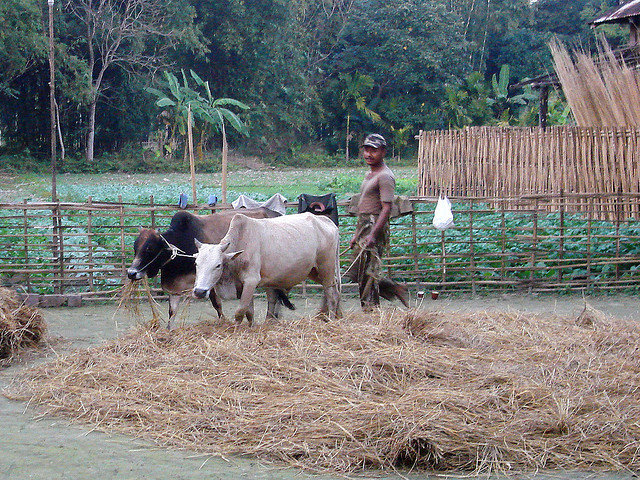What diet are the cows here on?
A. milk
B. fasting
C. vegan
D. carnivorous
Answer with the option's letter from the given choices directly. C What keeps the cattle from eating the garden here?
A. nothing
B. fear
C. man
D. fencing D 